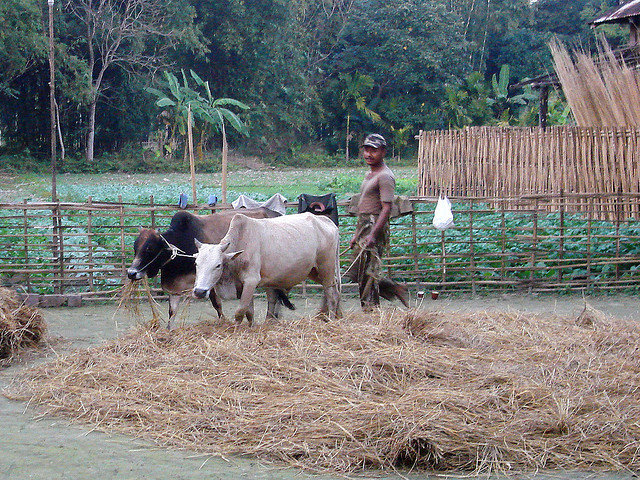What diet are the cows here on?
A. milk
B. fasting
C. vegan
D. carnivorous
Answer with the option's letter from the given choices directly. C What keeps the cattle from eating the garden here?
A. nothing
B. fear
C. man
D. fencing D 